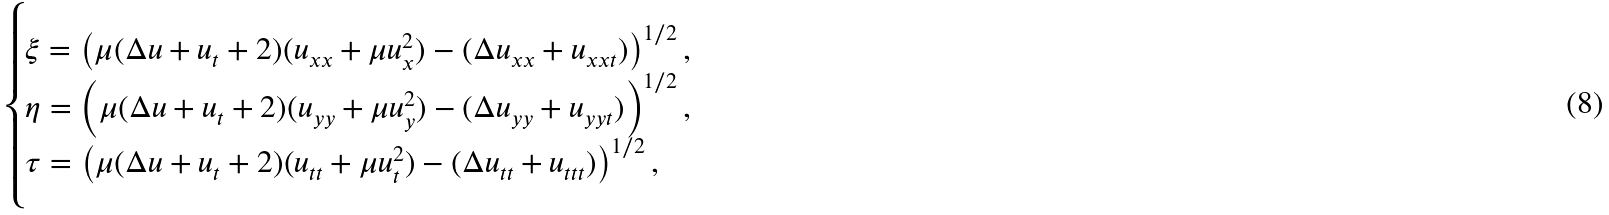Convert formula to latex. <formula><loc_0><loc_0><loc_500><loc_500>\begin{cases} \xi = \left ( \mu ( \Delta u + u _ { t } + 2 ) ( u _ { x x } + \mu u _ { x } ^ { 2 } ) - ( \Delta u _ { x x } + u _ { x x t } ) \right ) ^ { 1 / 2 } , \\ \eta = \left ( \mu ( \Delta u + u _ { t } + 2 ) ( u _ { y y } + \mu u _ { y } ^ { 2 } ) - ( \Delta u _ { y y } + u _ { y y t } ) \right ) ^ { 1 / 2 } , \\ \tau = \left ( \mu ( \Delta u + u _ { t } + 2 ) ( u _ { t t } + \mu u _ { t } ^ { 2 } ) - ( \Delta u _ { t t } + u _ { t t t } ) \right ) ^ { 1 / 2 } , \end{cases}</formula> 